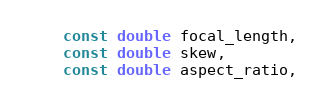Convert code to text. <code><loc_0><loc_0><loc_500><loc_500><_C_>    const double focal_length,
    const double skew,
    const double aspect_ratio,</code> 